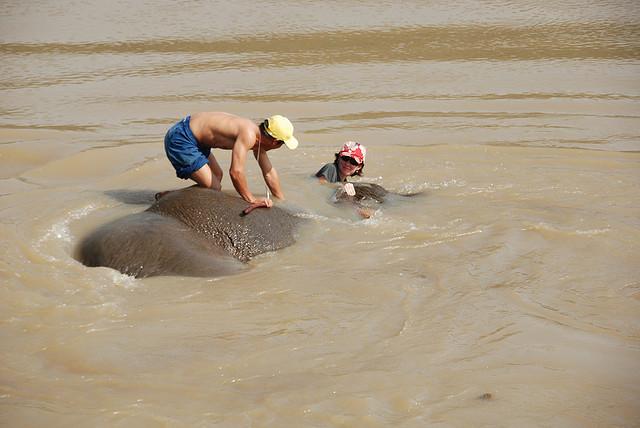Is the man soaked?
Be succinct. Yes. What is on the man's head?
Concise answer only. Hat. What is the man on a surfboard in the photo?
Be succinct. No. What is the man with blue shorts kneeling on?
Quick response, please. Sand. What beach has this photograph been taken at?
Give a very brief answer. South. What animal is in the water?
Give a very brief answer. Elephant. How many people are pictured?
Short answer required. 2. 